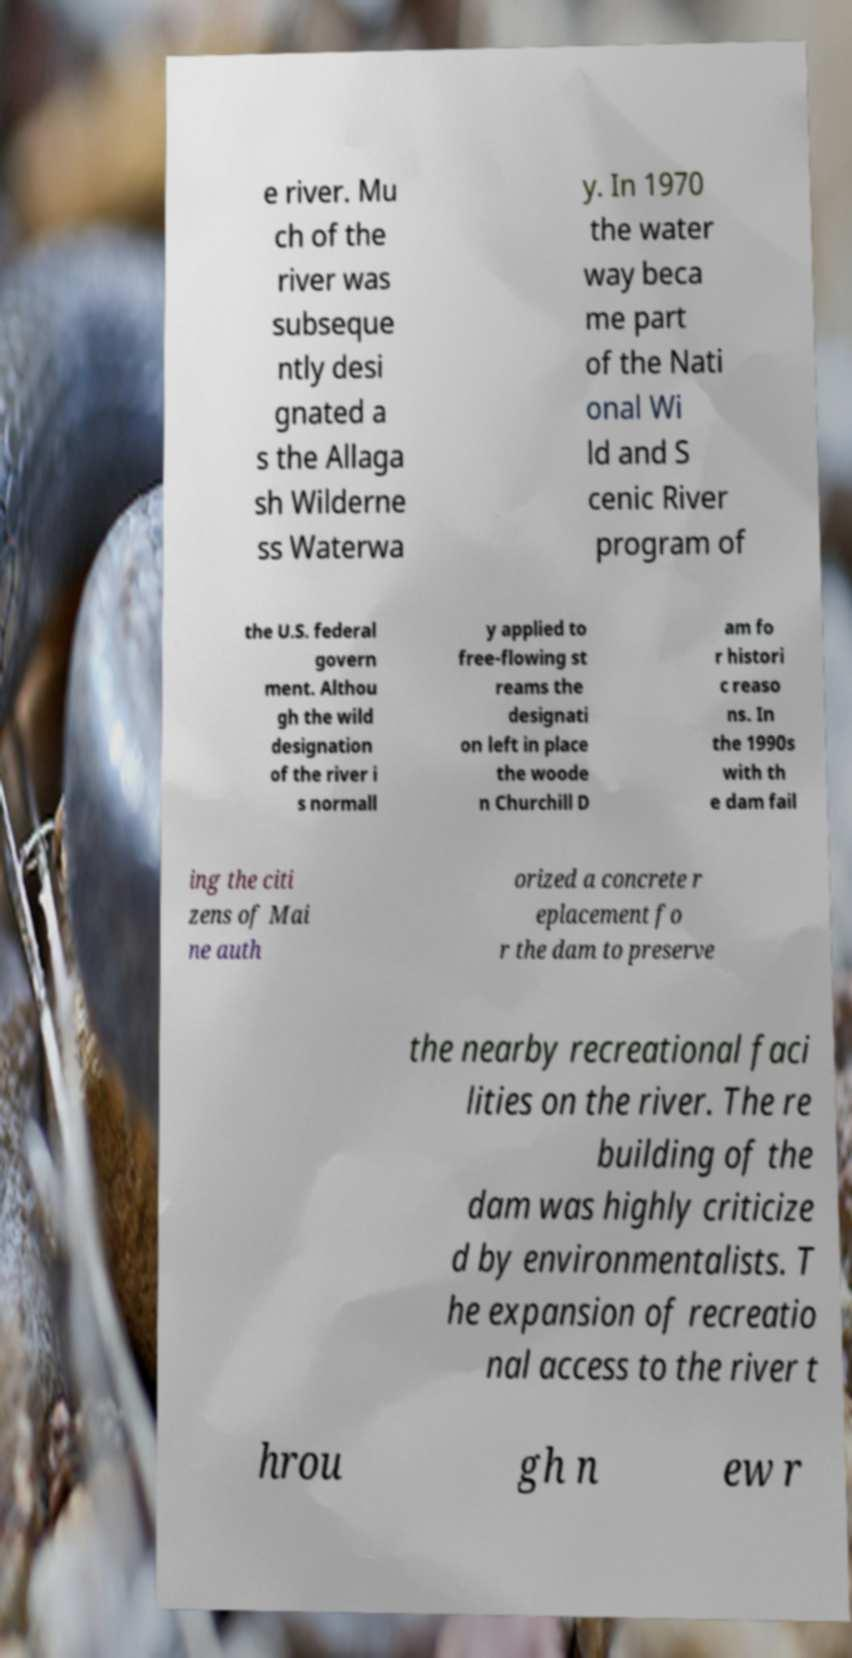Can you read and provide the text displayed in the image?This photo seems to have some interesting text. Can you extract and type it out for me? e river. Mu ch of the river was subseque ntly desi gnated a s the Allaga sh Wilderne ss Waterwa y. In 1970 the water way beca me part of the Nati onal Wi ld and S cenic River program of the U.S. federal govern ment. Althou gh the wild designation of the river i s normall y applied to free-flowing st reams the designati on left in place the woode n Churchill D am fo r histori c reaso ns. In the 1990s with th e dam fail ing the citi zens of Mai ne auth orized a concrete r eplacement fo r the dam to preserve the nearby recreational faci lities on the river. The re building of the dam was highly criticize d by environmentalists. T he expansion of recreatio nal access to the river t hrou gh n ew r 